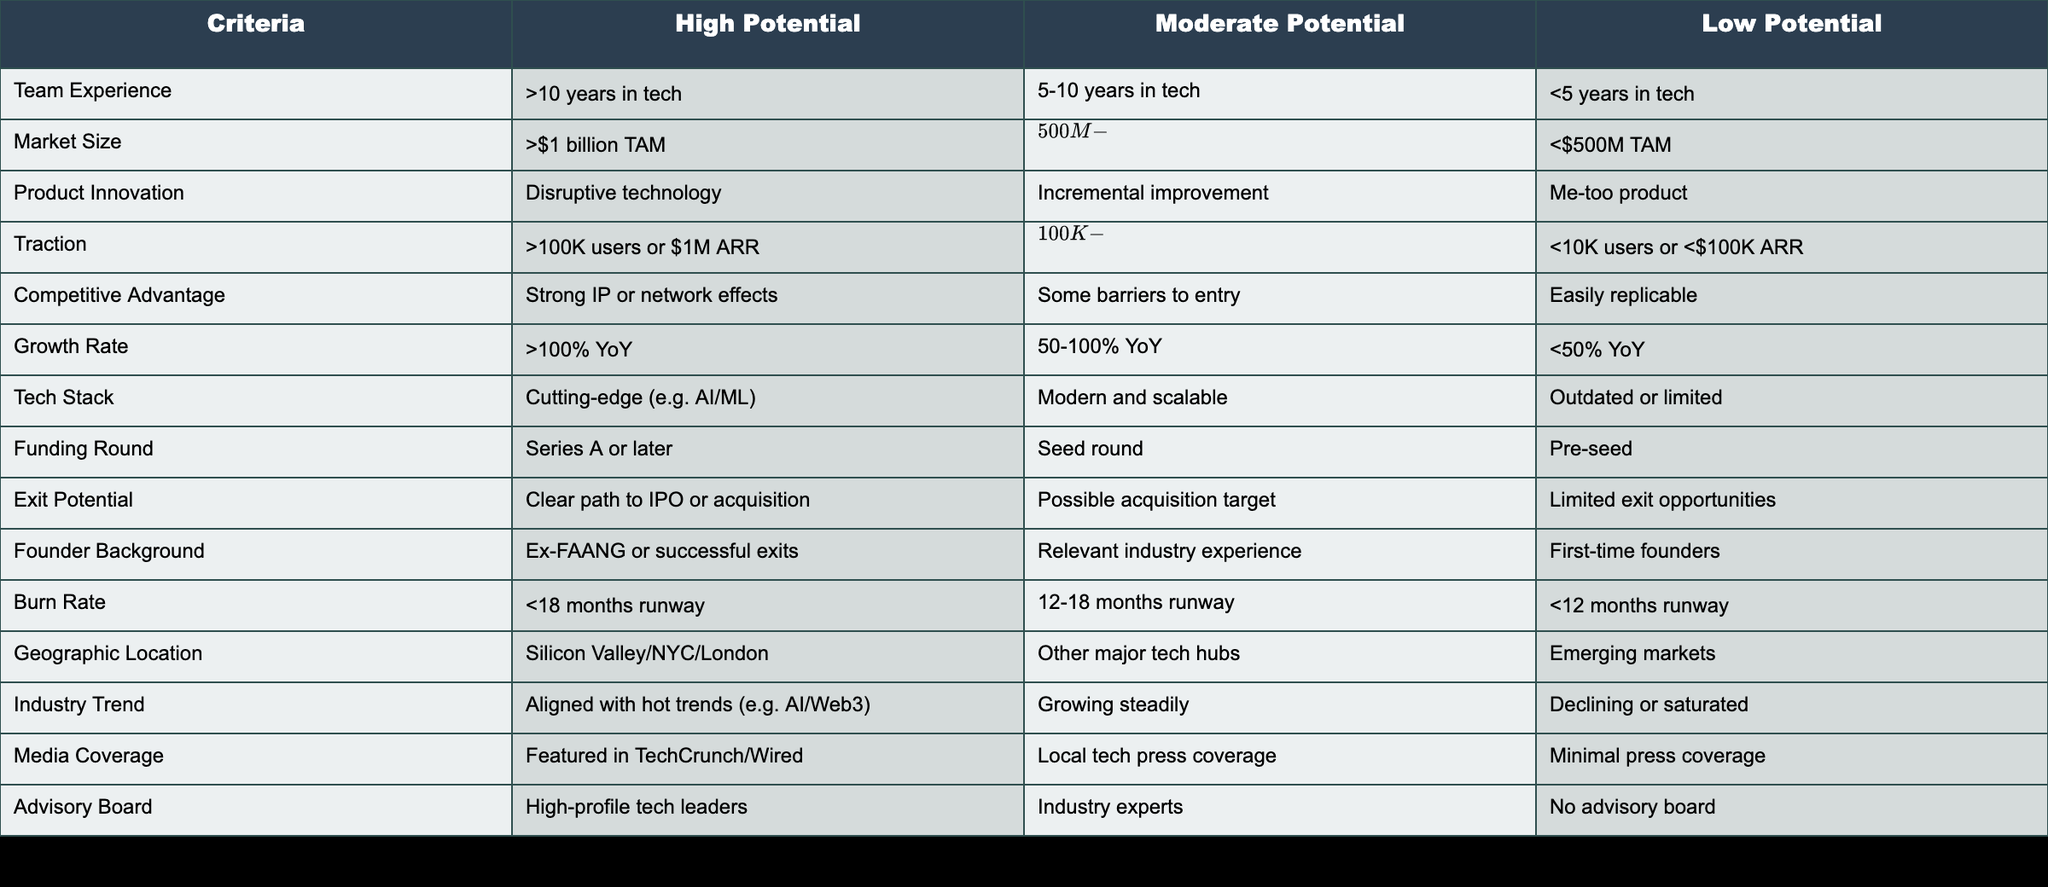What is the criteria when a startup has high potential for Market Size? According to the table, a startup is categorized under high potential for Market Size when it has a Total Addressable Market of more than $1 billion (TAM).
Answer: >$1 billion TAM What is the minimum traction needed for a startup to be considered of moderate potential? For a startup to be considered of moderate potential in terms of traction, it must have between 10,000 to 100,000 users or generate between $100,000 and $1 million in Annual Recurring Revenue (ARR).
Answer: 10K-100K users or $100K-$1M ARR Is a startup with a burn rate of less than 12 months runway considered high potential? No, startups with a burn rate of less than 12 months runway fall into the low potential category.
Answer: No What is the difference in Team Experience criteria between high and low potential startups? High potential startups need teams with more than 10 years of experience in tech, whereas low potential startups have teams with less than 5 years of experience in tech, indicating a significant difference of 6 or more years in experience.
Answer: 6 years For which criteria does a startup with a clear path to IPO or acquisition score high potential? A startup scores high potential under the Exit Potential criteria if it has a clear path to either an Initial Public Offering (IPO) or acquisition, highlighting the importance of exit opportunities.
Answer: Clear path to IPO or acquisition How many criteria support a high potential score for a startup in the context of financial health? Looking at factors related to financial health, a startup can obtain high potential based on traction and burn rate criteria. Therefore, there are two criteria that support high potential concerning financial health.
Answer: 2 criteria 